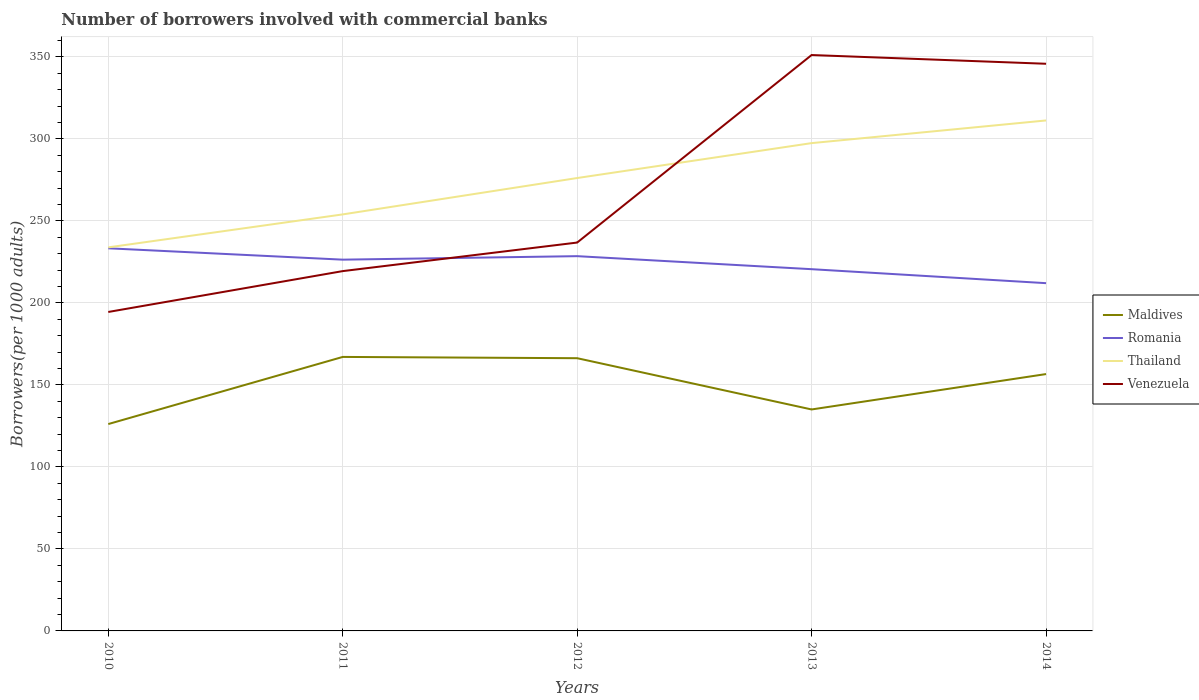Across all years, what is the maximum number of borrowers involved with commercial banks in Thailand?
Your answer should be compact. 233.87. What is the total number of borrowers involved with commercial banks in Romania in the graph?
Offer a very short reply. 8.52. What is the difference between the highest and the second highest number of borrowers involved with commercial banks in Thailand?
Ensure brevity in your answer.  77.38. Is the number of borrowers involved with commercial banks in Romania strictly greater than the number of borrowers involved with commercial banks in Venezuela over the years?
Your answer should be compact. No. How many years are there in the graph?
Offer a very short reply. 5. What is the difference between two consecutive major ticks on the Y-axis?
Make the answer very short. 50. Does the graph contain any zero values?
Keep it short and to the point. No. Where does the legend appear in the graph?
Provide a short and direct response. Center right. How are the legend labels stacked?
Your answer should be very brief. Vertical. What is the title of the graph?
Provide a short and direct response. Number of borrowers involved with commercial banks. What is the label or title of the Y-axis?
Offer a terse response. Borrowers(per 1000 adults). What is the Borrowers(per 1000 adults) in Maldives in 2010?
Provide a short and direct response. 126.14. What is the Borrowers(per 1000 adults) in Romania in 2010?
Make the answer very short. 233.3. What is the Borrowers(per 1000 adults) in Thailand in 2010?
Your response must be concise. 233.87. What is the Borrowers(per 1000 adults) of Venezuela in 2010?
Your response must be concise. 194.48. What is the Borrowers(per 1000 adults) in Maldives in 2011?
Ensure brevity in your answer.  167.07. What is the Borrowers(per 1000 adults) in Romania in 2011?
Your response must be concise. 226.38. What is the Borrowers(per 1000 adults) in Thailand in 2011?
Your response must be concise. 253.97. What is the Borrowers(per 1000 adults) of Venezuela in 2011?
Keep it short and to the point. 219.39. What is the Borrowers(per 1000 adults) of Maldives in 2012?
Provide a short and direct response. 166.29. What is the Borrowers(per 1000 adults) of Romania in 2012?
Provide a short and direct response. 228.51. What is the Borrowers(per 1000 adults) of Thailand in 2012?
Offer a terse response. 276.15. What is the Borrowers(per 1000 adults) in Venezuela in 2012?
Your answer should be compact. 236.81. What is the Borrowers(per 1000 adults) in Maldives in 2013?
Keep it short and to the point. 135.04. What is the Borrowers(per 1000 adults) of Romania in 2013?
Provide a succinct answer. 220.56. What is the Borrowers(per 1000 adults) in Thailand in 2013?
Make the answer very short. 297.44. What is the Borrowers(per 1000 adults) of Venezuela in 2013?
Your answer should be very brief. 351.15. What is the Borrowers(per 1000 adults) in Maldives in 2014?
Your answer should be compact. 156.61. What is the Borrowers(per 1000 adults) in Romania in 2014?
Give a very brief answer. 212.04. What is the Borrowers(per 1000 adults) in Thailand in 2014?
Keep it short and to the point. 311.25. What is the Borrowers(per 1000 adults) in Venezuela in 2014?
Make the answer very short. 345.82. Across all years, what is the maximum Borrowers(per 1000 adults) in Maldives?
Make the answer very short. 167.07. Across all years, what is the maximum Borrowers(per 1000 adults) in Romania?
Provide a short and direct response. 233.3. Across all years, what is the maximum Borrowers(per 1000 adults) of Thailand?
Make the answer very short. 311.25. Across all years, what is the maximum Borrowers(per 1000 adults) in Venezuela?
Your answer should be very brief. 351.15. Across all years, what is the minimum Borrowers(per 1000 adults) in Maldives?
Offer a very short reply. 126.14. Across all years, what is the minimum Borrowers(per 1000 adults) in Romania?
Your answer should be very brief. 212.04. Across all years, what is the minimum Borrowers(per 1000 adults) in Thailand?
Offer a very short reply. 233.87. Across all years, what is the minimum Borrowers(per 1000 adults) of Venezuela?
Ensure brevity in your answer.  194.48. What is the total Borrowers(per 1000 adults) in Maldives in the graph?
Give a very brief answer. 751.15. What is the total Borrowers(per 1000 adults) of Romania in the graph?
Provide a succinct answer. 1120.8. What is the total Borrowers(per 1000 adults) of Thailand in the graph?
Your answer should be compact. 1372.68. What is the total Borrowers(per 1000 adults) in Venezuela in the graph?
Provide a short and direct response. 1347.64. What is the difference between the Borrowers(per 1000 adults) of Maldives in 2010 and that in 2011?
Provide a succinct answer. -40.93. What is the difference between the Borrowers(per 1000 adults) in Romania in 2010 and that in 2011?
Offer a very short reply. 6.92. What is the difference between the Borrowers(per 1000 adults) of Thailand in 2010 and that in 2011?
Provide a succinct answer. -20.1. What is the difference between the Borrowers(per 1000 adults) in Venezuela in 2010 and that in 2011?
Give a very brief answer. -24.92. What is the difference between the Borrowers(per 1000 adults) of Maldives in 2010 and that in 2012?
Offer a terse response. -40.15. What is the difference between the Borrowers(per 1000 adults) in Romania in 2010 and that in 2012?
Give a very brief answer. 4.79. What is the difference between the Borrowers(per 1000 adults) in Thailand in 2010 and that in 2012?
Offer a terse response. -42.28. What is the difference between the Borrowers(per 1000 adults) in Venezuela in 2010 and that in 2012?
Your answer should be compact. -42.33. What is the difference between the Borrowers(per 1000 adults) of Maldives in 2010 and that in 2013?
Keep it short and to the point. -8.9. What is the difference between the Borrowers(per 1000 adults) of Romania in 2010 and that in 2013?
Provide a succinct answer. 12.74. What is the difference between the Borrowers(per 1000 adults) in Thailand in 2010 and that in 2013?
Your answer should be very brief. -63.57. What is the difference between the Borrowers(per 1000 adults) in Venezuela in 2010 and that in 2013?
Keep it short and to the point. -156.67. What is the difference between the Borrowers(per 1000 adults) of Maldives in 2010 and that in 2014?
Ensure brevity in your answer.  -30.48. What is the difference between the Borrowers(per 1000 adults) of Romania in 2010 and that in 2014?
Your answer should be compact. 21.26. What is the difference between the Borrowers(per 1000 adults) in Thailand in 2010 and that in 2014?
Provide a short and direct response. -77.38. What is the difference between the Borrowers(per 1000 adults) of Venezuela in 2010 and that in 2014?
Ensure brevity in your answer.  -151.34. What is the difference between the Borrowers(per 1000 adults) in Maldives in 2011 and that in 2012?
Offer a very short reply. 0.78. What is the difference between the Borrowers(per 1000 adults) in Romania in 2011 and that in 2012?
Offer a very short reply. -2.13. What is the difference between the Borrowers(per 1000 adults) in Thailand in 2011 and that in 2012?
Your response must be concise. -22.18. What is the difference between the Borrowers(per 1000 adults) in Venezuela in 2011 and that in 2012?
Your response must be concise. -17.41. What is the difference between the Borrowers(per 1000 adults) of Maldives in 2011 and that in 2013?
Give a very brief answer. 32.03. What is the difference between the Borrowers(per 1000 adults) of Romania in 2011 and that in 2013?
Your answer should be compact. 5.82. What is the difference between the Borrowers(per 1000 adults) in Thailand in 2011 and that in 2013?
Keep it short and to the point. -43.46. What is the difference between the Borrowers(per 1000 adults) of Venezuela in 2011 and that in 2013?
Provide a succinct answer. -131.76. What is the difference between the Borrowers(per 1000 adults) in Maldives in 2011 and that in 2014?
Offer a very short reply. 10.45. What is the difference between the Borrowers(per 1000 adults) in Romania in 2011 and that in 2014?
Provide a short and direct response. 14.34. What is the difference between the Borrowers(per 1000 adults) of Thailand in 2011 and that in 2014?
Make the answer very short. -57.28. What is the difference between the Borrowers(per 1000 adults) in Venezuela in 2011 and that in 2014?
Your response must be concise. -126.42. What is the difference between the Borrowers(per 1000 adults) of Maldives in 2012 and that in 2013?
Give a very brief answer. 31.25. What is the difference between the Borrowers(per 1000 adults) in Romania in 2012 and that in 2013?
Give a very brief answer. 7.95. What is the difference between the Borrowers(per 1000 adults) in Thailand in 2012 and that in 2013?
Your answer should be compact. -21.29. What is the difference between the Borrowers(per 1000 adults) of Venezuela in 2012 and that in 2013?
Offer a very short reply. -114.34. What is the difference between the Borrowers(per 1000 adults) in Maldives in 2012 and that in 2014?
Offer a very short reply. 9.68. What is the difference between the Borrowers(per 1000 adults) of Romania in 2012 and that in 2014?
Your answer should be compact. 16.47. What is the difference between the Borrowers(per 1000 adults) in Thailand in 2012 and that in 2014?
Keep it short and to the point. -35.11. What is the difference between the Borrowers(per 1000 adults) of Venezuela in 2012 and that in 2014?
Keep it short and to the point. -109.01. What is the difference between the Borrowers(per 1000 adults) of Maldives in 2013 and that in 2014?
Ensure brevity in your answer.  -21.58. What is the difference between the Borrowers(per 1000 adults) of Romania in 2013 and that in 2014?
Your response must be concise. 8.52. What is the difference between the Borrowers(per 1000 adults) in Thailand in 2013 and that in 2014?
Your answer should be very brief. -13.82. What is the difference between the Borrowers(per 1000 adults) of Venezuela in 2013 and that in 2014?
Ensure brevity in your answer.  5.33. What is the difference between the Borrowers(per 1000 adults) of Maldives in 2010 and the Borrowers(per 1000 adults) of Romania in 2011?
Provide a short and direct response. -100.24. What is the difference between the Borrowers(per 1000 adults) of Maldives in 2010 and the Borrowers(per 1000 adults) of Thailand in 2011?
Ensure brevity in your answer.  -127.83. What is the difference between the Borrowers(per 1000 adults) in Maldives in 2010 and the Borrowers(per 1000 adults) in Venezuela in 2011?
Provide a succinct answer. -93.26. What is the difference between the Borrowers(per 1000 adults) of Romania in 2010 and the Borrowers(per 1000 adults) of Thailand in 2011?
Ensure brevity in your answer.  -20.67. What is the difference between the Borrowers(per 1000 adults) in Romania in 2010 and the Borrowers(per 1000 adults) in Venezuela in 2011?
Make the answer very short. 13.91. What is the difference between the Borrowers(per 1000 adults) of Thailand in 2010 and the Borrowers(per 1000 adults) of Venezuela in 2011?
Your answer should be very brief. 14.48. What is the difference between the Borrowers(per 1000 adults) in Maldives in 2010 and the Borrowers(per 1000 adults) in Romania in 2012?
Offer a terse response. -102.37. What is the difference between the Borrowers(per 1000 adults) of Maldives in 2010 and the Borrowers(per 1000 adults) of Thailand in 2012?
Give a very brief answer. -150.01. What is the difference between the Borrowers(per 1000 adults) of Maldives in 2010 and the Borrowers(per 1000 adults) of Venezuela in 2012?
Ensure brevity in your answer.  -110.67. What is the difference between the Borrowers(per 1000 adults) of Romania in 2010 and the Borrowers(per 1000 adults) of Thailand in 2012?
Provide a succinct answer. -42.85. What is the difference between the Borrowers(per 1000 adults) of Romania in 2010 and the Borrowers(per 1000 adults) of Venezuela in 2012?
Your answer should be compact. -3.51. What is the difference between the Borrowers(per 1000 adults) of Thailand in 2010 and the Borrowers(per 1000 adults) of Venezuela in 2012?
Ensure brevity in your answer.  -2.94. What is the difference between the Borrowers(per 1000 adults) in Maldives in 2010 and the Borrowers(per 1000 adults) in Romania in 2013?
Offer a very short reply. -94.42. What is the difference between the Borrowers(per 1000 adults) in Maldives in 2010 and the Borrowers(per 1000 adults) in Thailand in 2013?
Offer a terse response. -171.3. What is the difference between the Borrowers(per 1000 adults) in Maldives in 2010 and the Borrowers(per 1000 adults) in Venezuela in 2013?
Your response must be concise. -225.01. What is the difference between the Borrowers(per 1000 adults) in Romania in 2010 and the Borrowers(per 1000 adults) in Thailand in 2013?
Make the answer very short. -64.14. What is the difference between the Borrowers(per 1000 adults) of Romania in 2010 and the Borrowers(per 1000 adults) of Venezuela in 2013?
Give a very brief answer. -117.85. What is the difference between the Borrowers(per 1000 adults) of Thailand in 2010 and the Borrowers(per 1000 adults) of Venezuela in 2013?
Provide a succinct answer. -117.28. What is the difference between the Borrowers(per 1000 adults) in Maldives in 2010 and the Borrowers(per 1000 adults) in Romania in 2014?
Offer a terse response. -85.9. What is the difference between the Borrowers(per 1000 adults) of Maldives in 2010 and the Borrowers(per 1000 adults) of Thailand in 2014?
Provide a short and direct response. -185.12. What is the difference between the Borrowers(per 1000 adults) of Maldives in 2010 and the Borrowers(per 1000 adults) of Venezuela in 2014?
Offer a very short reply. -219.68. What is the difference between the Borrowers(per 1000 adults) in Romania in 2010 and the Borrowers(per 1000 adults) in Thailand in 2014?
Your response must be concise. -77.95. What is the difference between the Borrowers(per 1000 adults) of Romania in 2010 and the Borrowers(per 1000 adults) of Venezuela in 2014?
Ensure brevity in your answer.  -112.52. What is the difference between the Borrowers(per 1000 adults) in Thailand in 2010 and the Borrowers(per 1000 adults) in Venezuela in 2014?
Offer a very short reply. -111.95. What is the difference between the Borrowers(per 1000 adults) of Maldives in 2011 and the Borrowers(per 1000 adults) of Romania in 2012?
Provide a succinct answer. -61.45. What is the difference between the Borrowers(per 1000 adults) of Maldives in 2011 and the Borrowers(per 1000 adults) of Thailand in 2012?
Give a very brief answer. -109.08. What is the difference between the Borrowers(per 1000 adults) in Maldives in 2011 and the Borrowers(per 1000 adults) in Venezuela in 2012?
Your response must be concise. -69.74. What is the difference between the Borrowers(per 1000 adults) in Romania in 2011 and the Borrowers(per 1000 adults) in Thailand in 2012?
Ensure brevity in your answer.  -49.77. What is the difference between the Borrowers(per 1000 adults) of Romania in 2011 and the Borrowers(per 1000 adults) of Venezuela in 2012?
Your answer should be very brief. -10.43. What is the difference between the Borrowers(per 1000 adults) of Thailand in 2011 and the Borrowers(per 1000 adults) of Venezuela in 2012?
Your answer should be very brief. 17.17. What is the difference between the Borrowers(per 1000 adults) in Maldives in 2011 and the Borrowers(per 1000 adults) in Romania in 2013?
Your answer should be very brief. -53.5. What is the difference between the Borrowers(per 1000 adults) in Maldives in 2011 and the Borrowers(per 1000 adults) in Thailand in 2013?
Your answer should be compact. -130.37. What is the difference between the Borrowers(per 1000 adults) in Maldives in 2011 and the Borrowers(per 1000 adults) in Venezuela in 2013?
Provide a succinct answer. -184.08. What is the difference between the Borrowers(per 1000 adults) of Romania in 2011 and the Borrowers(per 1000 adults) of Thailand in 2013?
Offer a terse response. -71.06. What is the difference between the Borrowers(per 1000 adults) in Romania in 2011 and the Borrowers(per 1000 adults) in Venezuela in 2013?
Ensure brevity in your answer.  -124.77. What is the difference between the Borrowers(per 1000 adults) in Thailand in 2011 and the Borrowers(per 1000 adults) in Venezuela in 2013?
Your response must be concise. -97.18. What is the difference between the Borrowers(per 1000 adults) in Maldives in 2011 and the Borrowers(per 1000 adults) in Romania in 2014?
Ensure brevity in your answer.  -44.98. What is the difference between the Borrowers(per 1000 adults) in Maldives in 2011 and the Borrowers(per 1000 adults) in Thailand in 2014?
Provide a succinct answer. -144.19. What is the difference between the Borrowers(per 1000 adults) in Maldives in 2011 and the Borrowers(per 1000 adults) in Venezuela in 2014?
Provide a succinct answer. -178.75. What is the difference between the Borrowers(per 1000 adults) of Romania in 2011 and the Borrowers(per 1000 adults) of Thailand in 2014?
Make the answer very short. -84.87. What is the difference between the Borrowers(per 1000 adults) of Romania in 2011 and the Borrowers(per 1000 adults) of Venezuela in 2014?
Provide a succinct answer. -119.44. What is the difference between the Borrowers(per 1000 adults) of Thailand in 2011 and the Borrowers(per 1000 adults) of Venezuela in 2014?
Keep it short and to the point. -91.85. What is the difference between the Borrowers(per 1000 adults) in Maldives in 2012 and the Borrowers(per 1000 adults) in Romania in 2013?
Keep it short and to the point. -54.27. What is the difference between the Borrowers(per 1000 adults) of Maldives in 2012 and the Borrowers(per 1000 adults) of Thailand in 2013?
Provide a succinct answer. -131.15. What is the difference between the Borrowers(per 1000 adults) in Maldives in 2012 and the Borrowers(per 1000 adults) in Venezuela in 2013?
Provide a short and direct response. -184.86. What is the difference between the Borrowers(per 1000 adults) in Romania in 2012 and the Borrowers(per 1000 adults) in Thailand in 2013?
Your answer should be very brief. -68.92. What is the difference between the Borrowers(per 1000 adults) of Romania in 2012 and the Borrowers(per 1000 adults) of Venezuela in 2013?
Make the answer very short. -122.64. What is the difference between the Borrowers(per 1000 adults) of Thailand in 2012 and the Borrowers(per 1000 adults) of Venezuela in 2013?
Provide a short and direct response. -75. What is the difference between the Borrowers(per 1000 adults) of Maldives in 2012 and the Borrowers(per 1000 adults) of Romania in 2014?
Ensure brevity in your answer.  -45.75. What is the difference between the Borrowers(per 1000 adults) of Maldives in 2012 and the Borrowers(per 1000 adults) of Thailand in 2014?
Offer a very short reply. -144.96. What is the difference between the Borrowers(per 1000 adults) in Maldives in 2012 and the Borrowers(per 1000 adults) in Venezuela in 2014?
Ensure brevity in your answer.  -179.53. What is the difference between the Borrowers(per 1000 adults) of Romania in 2012 and the Borrowers(per 1000 adults) of Thailand in 2014?
Ensure brevity in your answer.  -82.74. What is the difference between the Borrowers(per 1000 adults) of Romania in 2012 and the Borrowers(per 1000 adults) of Venezuela in 2014?
Provide a short and direct response. -117.31. What is the difference between the Borrowers(per 1000 adults) of Thailand in 2012 and the Borrowers(per 1000 adults) of Venezuela in 2014?
Ensure brevity in your answer.  -69.67. What is the difference between the Borrowers(per 1000 adults) in Maldives in 2013 and the Borrowers(per 1000 adults) in Romania in 2014?
Offer a very short reply. -77. What is the difference between the Borrowers(per 1000 adults) in Maldives in 2013 and the Borrowers(per 1000 adults) in Thailand in 2014?
Keep it short and to the point. -176.22. What is the difference between the Borrowers(per 1000 adults) of Maldives in 2013 and the Borrowers(per 1000 adults) of Venezuela in 2014?
Make the answer very short. -210.78. What is the difference between the Borrowers(per 1000 adults) in Romania in 2013 and the Borrowers(per 1000 adults) in Thailand in 2014?
Your response must be concise. -90.69. What is the difference between the Borrowers(per 1000 adults) in Romania in 2013 and the Borrowers(per 1000 adults) in Venezuela in 2014?
Ensure brevity in your answer.  -125.26. What is the difference between the Borrowers(per 1000 adults) of Thailand in 2013 and the Borrowers(per 1000 adults) of Venezuela in 2014?
Ensure brevity in your answer.  -48.38. What is the average Borrowers(per 1000 adults) of Maldives per year?
Keep it short and to the point. 150.23. What is the average Borrowers(per 1000 adults) of Romania per year?
Your answer should be very brief. 224.16. What is the average Borrowers(per 1000 adults) of Thailand per year?
Provide a succinct answer. 274.54. What is the average Borrowers(per 1000 adults) of Venezuela per year?
Provide a short and direct response. 269.53. In the year 2010, what is the difference between the Borrowers(per 1000 adults) of Maldives and Borrowers(per 1000 adults) of Romania?
Give a very brief answer. -107.16. In the year 2010, what is the difference between the Borrowers(per 1000 adults) in Maldives and Borrowers(per 1000 adults) in Thailand?
Make the answer very short. -107.73. In the year 2010, what is the difference between the Borrowers(per 1000 adults) of Maldives and Borrowers(per 1000 adults) of Venezuela?
Give a very brief answer. -68.34. In the year 2010, what is the difference between the Borrowers(per 1000 adults) in Romania and Borrowers(per 1000 adults) in Thailand?
Your answer should be very brief. -0.57. In the year 2010, what is the difference between the Borrowers(per 1000 adults) in Romania and Borrowers(per 1000 adults) in Venezuela?
Ensure brevity in your answer.  38.82. In the year 2010, what is the difference between the Borrowers(per 1000 adults) in Thailand and Borrowers(per 1000 adults) in Venezuela?
Your answer should be compact. 39.39. In the year 2011, what is the difference between the Borrowers(per 1000 adults) of Maldives and Borrowers(per 1000 adults) of Romania?
Your answer should be compact. -59.31. In the year 2011, what is the difference between the Borrowers(per 1000 adults) of Maldives and Borrowers(per 1000 adults) of Thailand?
Give a very brief answer. -86.91. In the year 2011, what is the difference between the Borrowers(per 1000 adults) in Maldives and Borrowers(per 1000 adults) in Venezuela?
Your response must be concise. -52.33. In the year 2011, what is the difference between the Borrowers(per 1000 adults) in Romania and Borrowers(per 1000 adults) in Thailand?
Offer a very short reply. -27.59. In the year 2011, what is the difference between the Borrowers(per 1000 adults) in Romania and Borrowers(per 1000 adults) in Venezuela?
Your response must be concise. 6.99. In the year 2011, what is the difference between the Borrowers(per 1000 adults) in Thailand and Borrowers(per 1000 adults) in Venezuela?
Make the answer very short. 34.58. In the year 2012, what is the difference between the Borrowers(per 1000 adults) of Maldives and Borrowers(per 1000 adults) of Romania?
Provide a succinct answer. -62.22. In the year 2012, what is the difference between the Borrowers(per 1000 adults) in Maldives and Borrowers(per 1000 adults) in Thailand?
Offer a very short reply. -109.86. In the year 2012, what is the difference between the Borrowers(per 1000 adults) of Maldives and Borrowers(per 1000 adults) of Venezuela?
Your response must be concise. -70.52. In the year 2012, what is the difference between the Borrowers(per 1000 adults) in Romania and Borrowers(per 1000 adults) in Thailand?
Offer a very short reply. -47.64. In the year 2012, what is the difference between the Borrowers(per 1000 adults) of Romania and Borrowers(per 1000 adults) of Venezuela?
Offer a terse response. -8.3. In the year 2012, what is the difference between the Borrowers(per 1000 adults) in Thailand and Borrowers(per 1000 adults) in Venezuela?
Provide a short and direct response. 39.34. In the year 2013, what is the difference between the Borrowers(per 1000 adults) in Maldives and Borrowers(per 1000 adults) in Romania?
Make the answer very short. -85.52. In the year 2013, what is the difference between the Borrowers(per 1000 adults) of Maldives and Borrowers(per 1000 adults) of Thailand?
Ensure brevity in your answer.  -162.4. In the year 2013, what is the difference between the Borrowers(per 1000 adults) of Maldives and Borrowers(per 1000 adults) of Venezuela?
Provide a succinct answer. -216.11. In the year 2013, what is the difference between the Borrowers(per 1000 adults) in Romania and Borrowers(per 1000 adults) in Thailand?
Your response must be concise. -76.87. In the year 2013, what is the difference between the Borrowers(per 1000 adults) in Romania and Borrowers(per 1000 adults) in Venezuela?
Your answer should be very brief. -130.59. In the year 2013, what is the difference between the Borrowers(per 1000 adults) in Thailand and Borrowers(per 1000 adults) in Venezuela?
Your answer should be very brief. -53.71. In the year 2014, what is the difference between the Borrowers(per 1000 adults) of Maldives and Borrowers(per 1000 adults) of Romania?
Give a very brief answer. -55.43. In the year 2014, what is the difference between the Borrowers(per 1000 adults) in Maldives and Borrowers(per 1000 adults) in Thailand?
Ensure brevity in your answer.  -154.64. In the year 2014, what is the difference between the Borrowers(per 1000 adults) of Maldives and Borrowers(per 1000 adults) of Venezuela?
Your answer should be compact. -189.2. In the year 2014, what is the difference between the Borrowers(per 1000 adults) of Romania and Borrowers(per 1000 adults) of Thailand?
Your answer should be compact. -99.21. In the year 2014, what is the difference between the Borrowers(per 1000 adults) in Romania and Borrowers(per 1000 adults) in Venezuela?
Make the answer very short. -133.78. In the year 2014, what is the difference between the Borrowers(per 1000 adults) of Thailand and Borrowers(per 1000 adults) of Venezuela?
Make the answer very short. -34.56. What is the ratio of the Borrowers(per 1000 adults) of Maldives in 2010 to that in 2011?
Ensure brevity in your answer.  0.76. What is the ratio of the Borrowers(per 1000 adults) in Romania in 2010 to that in 2011?
Provide a short and direct response. 1.03. What is the ratio of the Borrowers(per 1000 adults) of Thailand in 2010 to that in 2011?
Offer a terse response. 0.92. What is the ratio of the Borrowers(per 1000 adults) in Venezuela in 2010 to that in 2011?
Offer a very short reply. 0.89. What is the ratio of the Borrowers(per 1000 adults) in Maldives in 2010 to that in 2012?
Provide a short and direct response. 0.76. What is the ratio of the Borrowers(per 1000 adults) in Romania in 2010 to that in 2012?
Ensure brevity in your answer.  1.02. What is the ratio of the Borrowers(per 1000 adults) in Thailand in 2010 to that in 2012?
Offer a very short reply. 0.85. What is the ratio of the Borrowers(per 1000 adults) of Venezuela in 2010 to that in 2012?
Ensure brevity in your answer.  0.82. What is the ratio of the Borrowers(per 1000 adults) of Maldives in 2010 to that in 2013?
Your response must be concise. 0.93. What is the ratio of the Borrowers(per 1000 adults) of Romania in 2010 to that in 2013?
Your answer should be compact. 1.06. What is the ratio of the Borrowers(per 1000 adults) of Thailand in 2010 to that in 2013?
Your answer should be compact. 0.79. What is the ratio of the Borrowers(per 1000 adults) in Venezuela in 2010 to that in 2013?
Make the answer very short. 0.55. What is the ratio of the Borrowers(per 1000 adults) in Maldives in 2010 to that in 2014?
Offer a terse response. 0.81. What is the ratio of the Borrowers(per 1000 adults) of Romania in 2010 to that in 2014?
Make the answer very short. 1.1. What is the ratio of the Borrowers(per 1000 adults) in Thailand in 2010 to that in 2014?
Offer a terse response. 0.75. What is the ratio of the Borrowers(per 1000 adults) of Venezuela in 2010 to that in 2014?
Your answer should be compact. 0.56. What is the ratio of the Borrowers(per 1000 adults) in Romania in 2011 to that in 2012?
Give a very brief answer. 0.99. What is the ratio of the Borrowers(per 1000 adults) in Thailand in 2011 to that in 2012?
Your answer should be very brief. 0.92. What is the ratio of the Borrowers(per 1000 adults) in Venezuela in 2011 to that in 2012?
Give a very brief answer. 0.93. What is the ratio of the Borrowers(per 1000 adults) of Maldives in 2011 to that in 2013?
Ensure brevity in your answer.  1.24. What is the ratio of the Borrowers(per 1000 adults) in Romania in 2011 to that in 2013?
Your answer should be very brief. 1.03. What is the ratio of the Borrowers(per 1000 adults) in Thailand in 2011 to that in 2013?
Your answer should be very brief. 0.85. What is the ratio of the Borrowers(per 1000 adults) of Venezuela in 2011 to that in 2013?
Your answer should be compact. 0.62. What is the ratio of the Borrowers(per 1000 adults) in Maldives in 2011 to that in 2014?
Offer a terse response. 1.07. What is the ratio of the Borrowers(per 1000 adults) of Romania in 2011 to that in 2014?
Your answer should be very brief. 1.07. What is the ratio of the Borrowers(per 1000 adults) in Thailand in 2011 to that in 2014?
Your answer should be compact. 0.82. What is the ratio of the Borrowers(per 1000 adults) of Venezuela in 2011 to that in 2014?
Provide a short and direct response. 0.63. What is the ratio of the Borrowers(per 1000 adults) in Maldives in 2012 to that in 2013?
Provide a succinct answer. 1.23. What is the ratio of the Borrowers(per 1000 adults) of Romania in 2012 to that in 2013?
Give a very brief answer. 1.04. What is the ratio of the Borrowers(per 1000 adults) of Thailand in 2012 to that in 2013?
Give a very brief answer. 0.93. What is the ratio of the Borrowers(per 1000 adults) of Venezuela in 2012 to that in 2013?
Keep it short and to the point. 0.67. What is the ratio of the Borrowers(per 1000 adults) of Maldives in 2012 to that in 2014?
Keep it short and to the point. 1.06. What is the ratio of the Borrowers(per 1000 adults) in Romania in 2012 to that in 2014?
Your response must be concise. 1.08. What is the ratio of the Borrowers(per 1000 adults) in Thailand in 2012 to that in 2014?
Offer a very short reply. 0.89. What is the ratio of the Borrowers(per 1000 adults) in Venezuela in 2012 to that in 2014?
Your answer should be very brief. 0.68. What is the ratio of the Borrowers(per 1000 adults) in Maldives in 2013 to that in 2014?
Offer a very short reply. 0.86. What is the ratio of the Borrowers(per 1000 adults) of Romania in 2013 to that in 2014?
Your answer should be compact. 1.04. What is the ratio of the Borrowers(per 1000 adults) in Thailand in 2013 to that in 2014?
Keep it short and to the point. 0.96. What is the ratio of the Borrowers(per 1000 adults) in Venezuela in 2013 to that in 2014?
Keep it short and to the point. 1.02. What is the difference between the highest and the second highest Borrowers(per 1000 adults) in Maldives?
Ensure brevity in your answer.  0.78. What is the difference between the highest and the second highest Borrowers(per 1000 adults) in Romania?
Your answer should be compact. 4.79. What is the difference between the highest and the second highest Borrowers(per 1000 adults) in Thailand?
Your answer should be very brief. 13.82. What is the difference between the highest and the second highest Borrowers(per 1000 adults) of Venezuela?
Your answer should be compact. 5.33. What is the difference between the highest and the lowest Borrowers(per 1000 adults) of Maldives?
Provide a short and direct response. 40.93. What is the difference between the highest and the lowest Borrowers(per 1000 adults) in Romania?
Your answer should be compact. 21.26. What is the difference between the highest and the lowest Borrowers(per 1000 adults) in Thailand?
Offer a very short reply. 77.38. What is the difference between the highest and the lowest Borrowers(per 1000 adults) of Venezuela?
Make the answer very short. 156.67. 